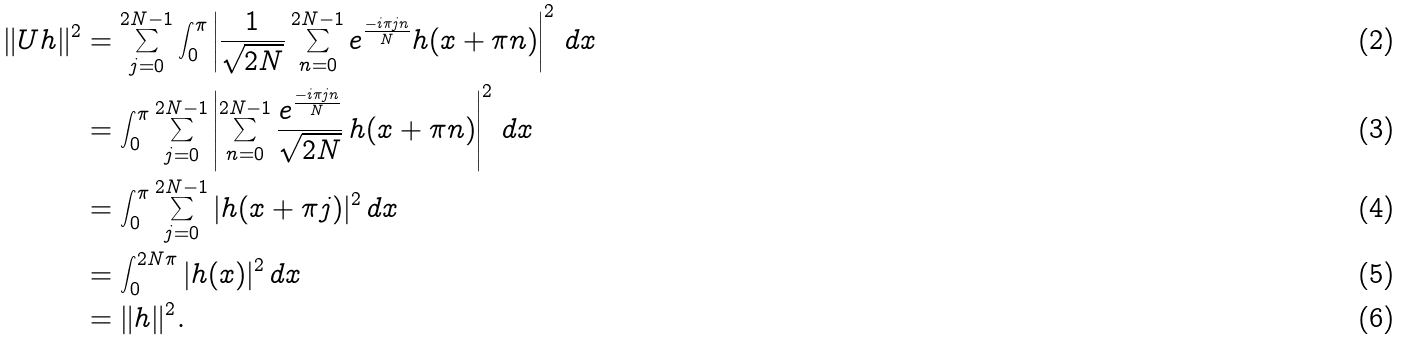<formula> <loc_0><loc_0><loc_500><loc_500>\| U h \| ^ { 2 } & = \sum _ { j = 0 } ^ { 2 N - 1 } \int _ { 0 } ^ { \pi } \left | \frac { 1 } { \sqrt { 2 N } } \sum _ { n = 0 } ^ { 2 N - 1 } e ^ { \frac { - i \pi j n } { N } } h ( x + \pi n ) \right | ^ { 2 } \, d x \\ & = \int _ { 0 } ^ { \pi } \sum _ { j = 0 } ^ { 2 N - 1 } \left | \sum _ { n = 0 } ^ { 2 N - 1 } \frac { e ^ { \frac { - i \pi j n } { N } } } { \sqrt { 2 N } } \, h ( x + \pi n ) \right | ^ { 2 } \, d x \\ & = \int _ { 0 } ^ { \pi } \sum _ { j = 0 } ^ { 2 N - 1 } | h ( x + \pi j ) | ^ { 2 } \, d x \\ & = \int _ { 0 } ^ { 2 N \pi } | h ( x ) | ^ { 2 } \, d x \\ & = \| h \| ^ { 2 } .</formula> 